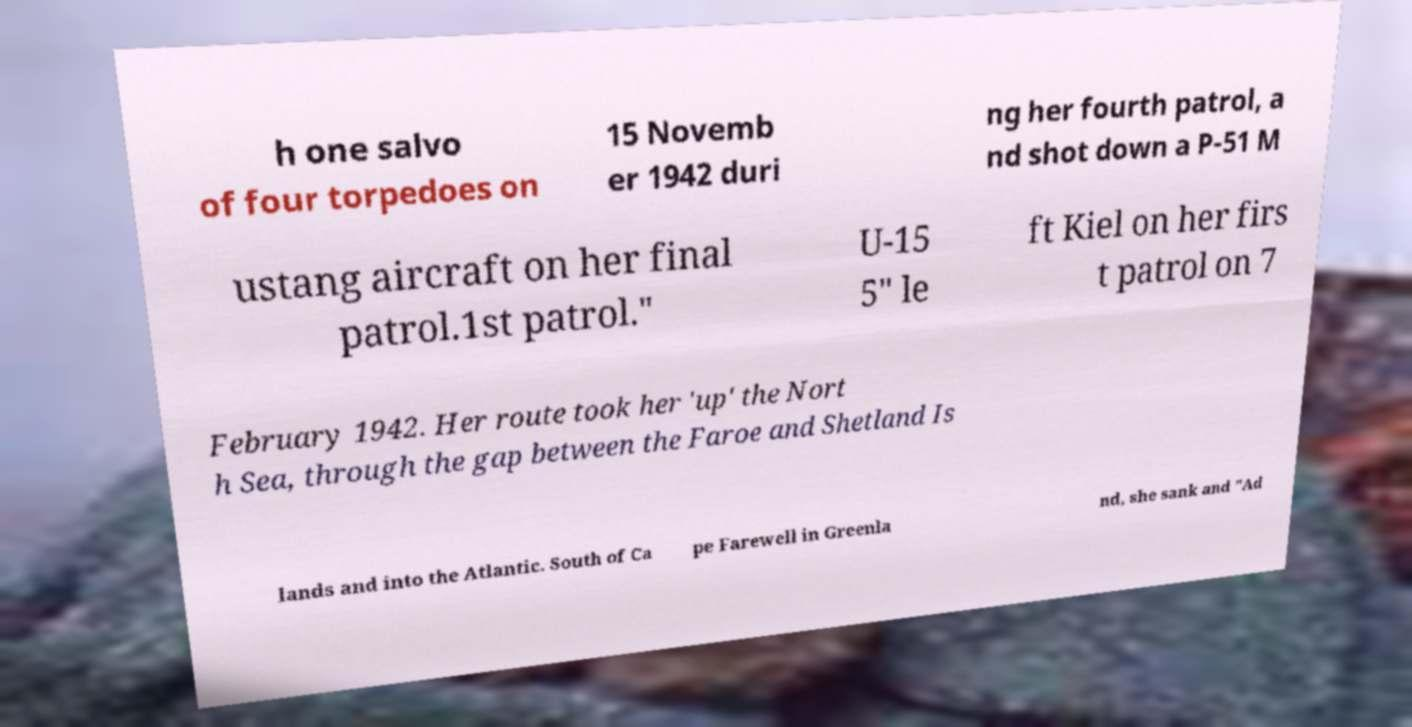Can you read and provide the text displayed in the image?This photo seems to have some interesting text. Can you extract and type it out for me? h one salvo of four torpedoes on 15 Novemb er 1942 duri ng her fourth patrol, a nd shot down a P-51 M ustang aircraft on her final patrol.1st patrol." U-15 5" le ft Kiel on her firs t patrol on 7 February 1942. Her route took her 'up' the Nort h Sea, through the gap between the Faroe and Shetland Is lands and into the Atlantic. South of Ca pe Farewell in Greenla nd, she sank and "Ad 